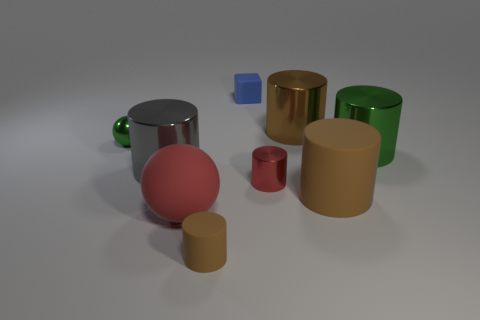Subtract all gray blocks. How many brown cylinders are left? 3 Subtract all red cylinders. How many cylinders are left? 5 Subtract all brown rubber cylinders. How many cylinders are left? 4 Subtract 2 cylinders. How many cylinders are left? 4 Subtract all red cylinders. Subtract all brown cubes. How many cylinders are left? 5 Add 1 large brown shiny cylinders. How many objects exist? 10 Subtract all cylinders. How many objects are left? 3 Add 4 large gray shiny cylinders. How many large gray shiny cylinders are left? 5 Add 7 small purple cubes. How many small purple cubes exist? 7 Subtract 1 green cylinders. How many objects are left? 8 